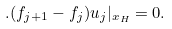Convert formula to latex. <formula><loc_0><loc_0><loc_500><loc_500>. ( f _ { j + 1 } - f _ { j } ) u _ { j } | _ { x _ { H } } = 0 .</formula> 